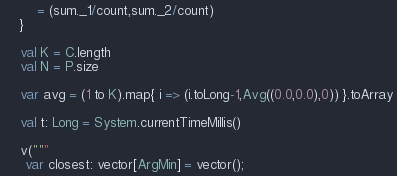Convert code to text. <code><loc_0><loc_0><loc_500><loc_500><_Scala_>        = (sum._1/count,sum._2/count)
    }

    val K = C.length
    val N = P.size

    var avg = (1 to K).map{ i => (i.toLong-1,Avg((0.0,0.0),0)) }.toArray

    val t: Long = System.currentTimeMillis()

    v("""
     var closest: vector[ArgMin] = vector();
</code> 